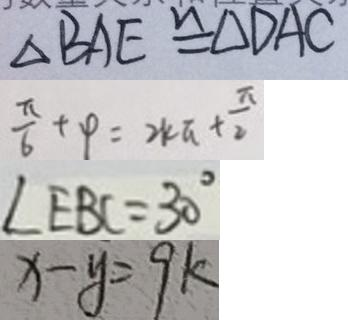Convert formula to latex. <formula><loc_0><loc_0><loc_500><loc_500>\Delta B A E \cong \Delta D A C 
 \frac { \pi } { 6 } + p = 2 k \pi + \frac { \pi } { 2 } 
 \angle E B C = 3 0 ^ { \circ } 
 x - y = 9 k</formula> 